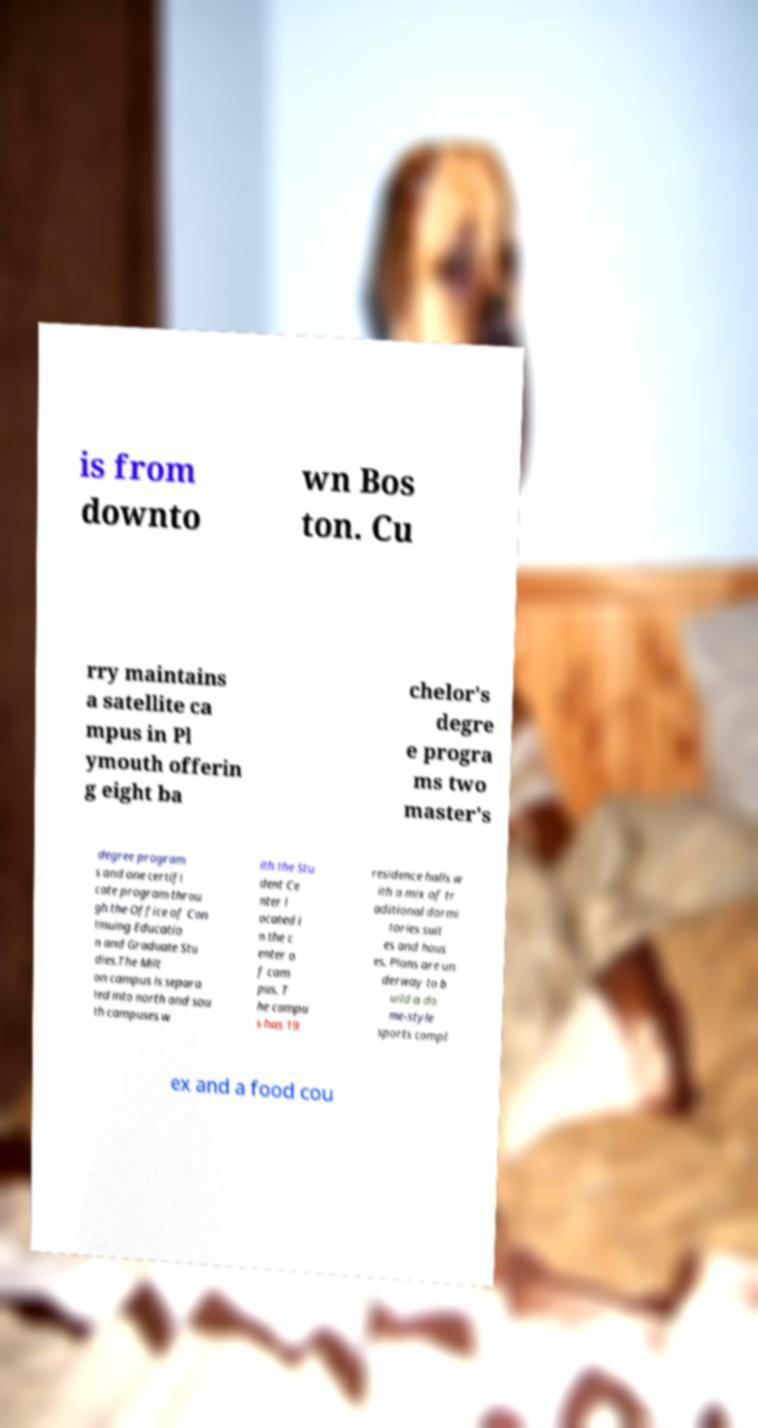Could you assist in decoding the text presented in this image and type it out clearly? is from downto wn Bos ton. Cu rry maintains a satellite ca mpus in Pl ymouth offerin g eight ba chelor's degre e progra ms two master's degree program s and one certifi cate program throu gh the Office of Con tinuing Educatio n and Graduate Stu dies.The Milt on campus is separa ted into north and sou th campuses w ith the Stu dent Ce nter l ocated i n the c enter o f cam pus. T he campu s has 19 residence halls w ith a mix of tr aditional dormi tories suit es and hous es. Plans are un derway to b uild a do me-style sports compl ex and a food cou 